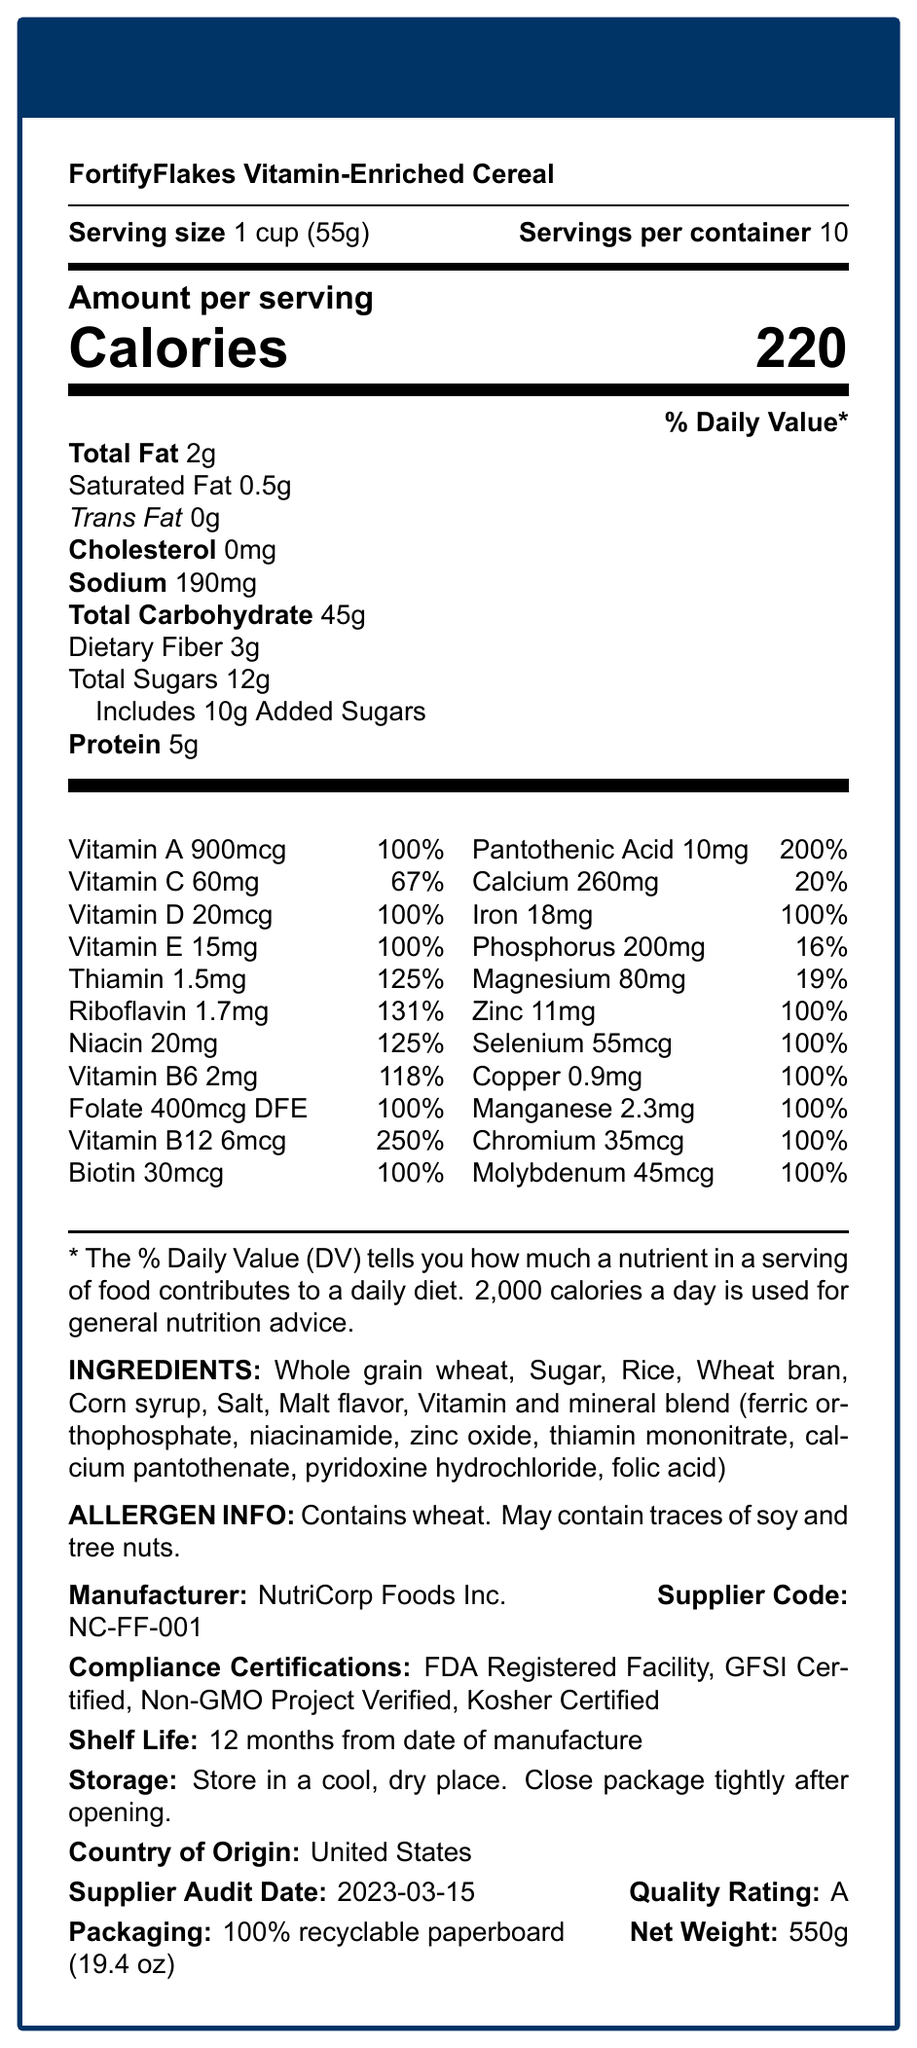what is the serving size of the cereal? The serving size is clearly listed under the product name and before the servings per container.
Answer: 1 cup (55g) how many calories are in one serving of FortifyFlakes? The calories per serving are prominently displayed in large text under "Amount per serving".
Answer: 220 what is the total fat content per serving? The total fat content per serving is listed in the table under "Total Fat".
Answer: 2g how much protein does one serving contain? The protein content per serving is listed in the table towards the bottom.
Answer: 5g which three vitamins have the highest daily value percentages? Vitamin B12 has 250%, Pantothenic Acid has 200%, Riboflavin has 131%.
Answer: Vitamin B12, Pantothenic Acid, Riboflavin what are the storage instructions for FortifyFlakes? The storage instructions are listed towards the bottom of the document under "Storage".
Answer: Store in a cool, dry place. Close package tightly after opening. how much added sugar does one serving contain? The amount of added sugars is listed under "Total Sugars" in the detailed table.
Answer: 10g which of the following certifications does FortifyFlakes have? A. USDA Organic B. Non-GMO Project Verified C. Fair Trade Certified D. Halal Certified The certifications are listed towards the bottom of the document under "Compliance Certifications".
Answer: B. Non-GMO Project Verified what percentage of daily value does one serving of FortifyFlakes provide for calcium? A. 8% B. 16% C. 19% D. 20% The calcium daily value percentage is listed in the table in the vitamins and minerals section.
Answer: D. 20% does FortifyFlakes contain any allergens? The allergen information states that it contains wheat and may contain traces of soy and tree nuts.
Answer: Yes what is the shelf life of the product? The shelf life is listed towards the bottom under "Shelf Life".
Answer: 12 months from date of manufacture summarize the main nutritional highlights of FortifyFlakes. The summary includes key points about calorie content, significant vitamins and minerals, added sugars, and compliance certifications.
Answer: FortifyFlakes Vitamin-Enriched Cereal contains 220 calories per serving, with added vitamins and minerals such as Vitamin B12 (250%), Pantothenic Acid (200%), and Riboflavin (131%). It includes 10g of added sugars and has a good balance of fat, fiber, and protein. The cereal also carries multiple compliance certifications, such as FDA Registered Facility and Non-GMO Project Verified. how many milligrams of sodium does each serving contain? The sodium content per serving is listed in the table under "Sodium".
Answer: 190mg is this cereal suitable for someone with a soy allergy? The allergen information states that it may contain traces of soy, so it might not be suitable for someone with a soy allergy.
Answer: Maybe who manufactures FortifyFlakes Vitamin-Enriched Cereal? The manufacturer is listed towards the bottom under "Manufacturer".
Answer: NutriCorp Foods Inc. what is the net weight of the entire container? The net weight is listed at the bottom of the document.
Answer: 550g (19.4 oz) when was the supplier last audited? The supplier audit date is specified towards the bottom of the document.
Answer: 2023-03-15 what type of packaging material is used for FortifyFlakes? The packaging material is mentioned towards the bottom under "Packaging".
Answer: 100% recyclable paperboard how many daily value percentages does Folate provide? The daily value percentage for Folate is listed in the vitamins and minerals section.
Answer: 100% what ingredients are included in the cereal's vitamin and mineral blend? The ingredients in the vitamin and mineral blend are listed under "INGREDIENTS" towards the bottom.
Answer: Ferric orthophosphate, niacinamide, zinc oxide, thiamin mononitrate, calcium pantothenate, pyridoxine hydrochloride, folic acid which vitamin provides 200% of the daily value? The daily value for Pantothenic Acid is listed as 200% in the vitamins and minerals section.
Answer: Pantothenic Acid how much Riboflavin is in each serving? The amount of Riboflavin is listed in the vitamins and minerals section as 1.7mg.
Answer: 1.7mg what is the main source of carbohydrate in this cereal? The document lists "Total Carbohydrate" as 45g, but it does not specify the main source of carbohydrates within the listed ingredients.
Answer: Cannot be determined 